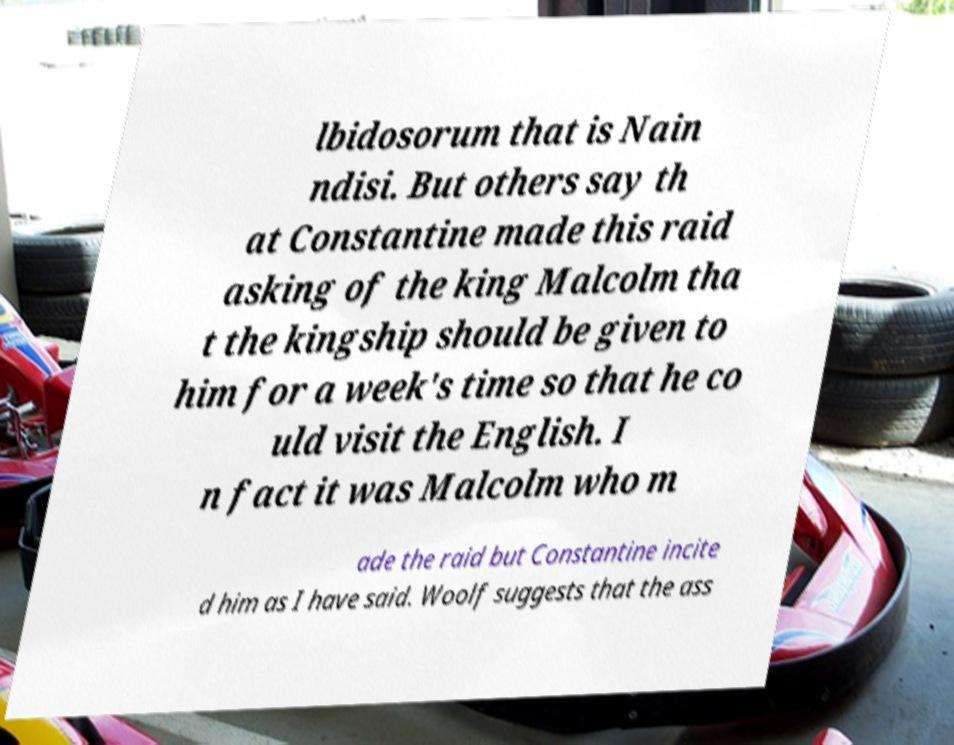What messages or text are displayed in this image? I need them in a readable, typed format. lbidosorum that is Nain ndisi. But others say th at Constantine made this raid asking of the king Malcolm tha t the kingship should be given to him for a week's time so that he co uld visit the English. I n fact it was Malcolm who m ade the raid but Constantine incite d him as I have said. Woolf suggests that the ass 